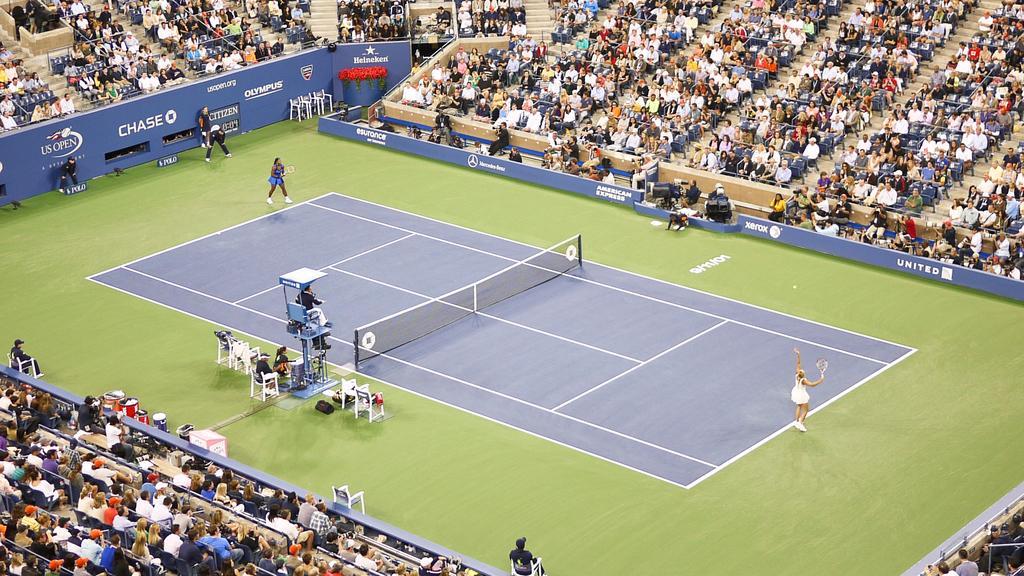Describe this image in one or two sentences. In this picture there are two persons standing and holding the bats. There are group of people sitting in the stadium and there are group of people sitting in the chairs. At the back there are three persons standing. In the middle of the image there is a net and there is a ball in the air. At the back there are boards and there is text on the boards. Behind the boards there are staircases and handrails. 